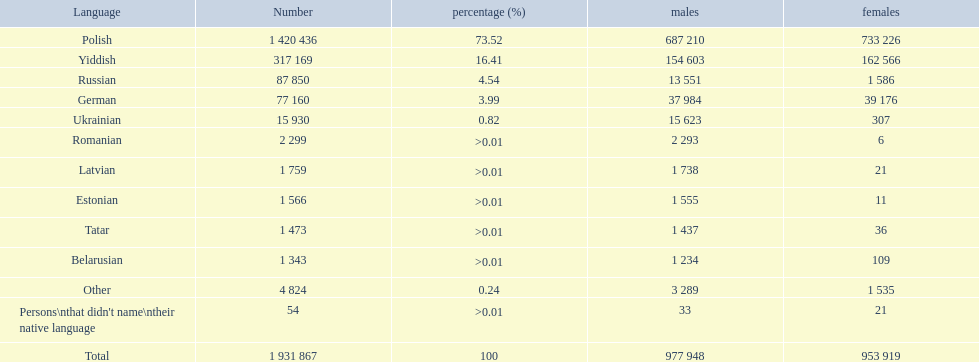What are the languages spoken by over 50,000 individuals? Polish, Yiddish, Russian, German. Among those, which ones are used by less than 15% of the population? Russian, German. Out of the last two, which language has 37,984 male speakers? German. 